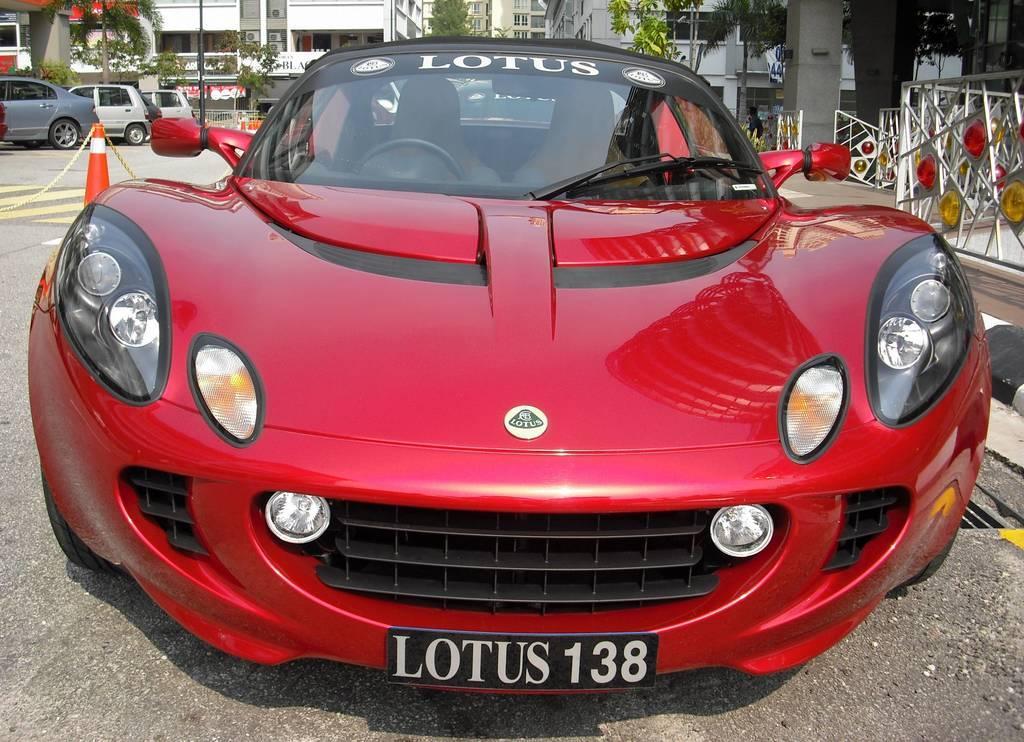Please provide a concise description of this image. In this image there are cars on a road, in the right there are iron rods, in the background there are trees and buildings. 